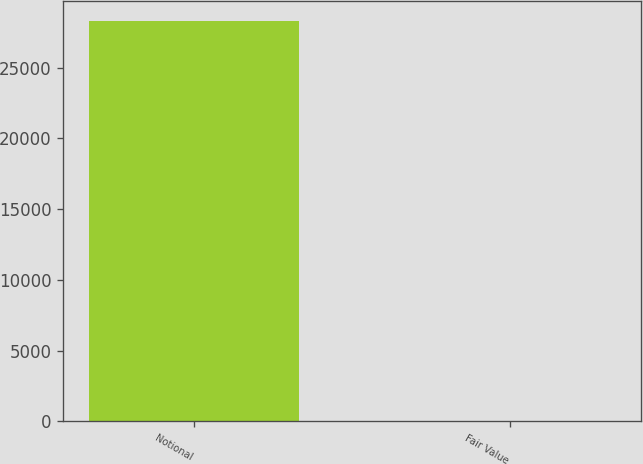<chart> <loc_0><loc_0><loc_500><loc_500><bar_chart><fcel>Notional<fcel>Fair Value<nl><fcel>28327<fcel>3<nl></chart> 